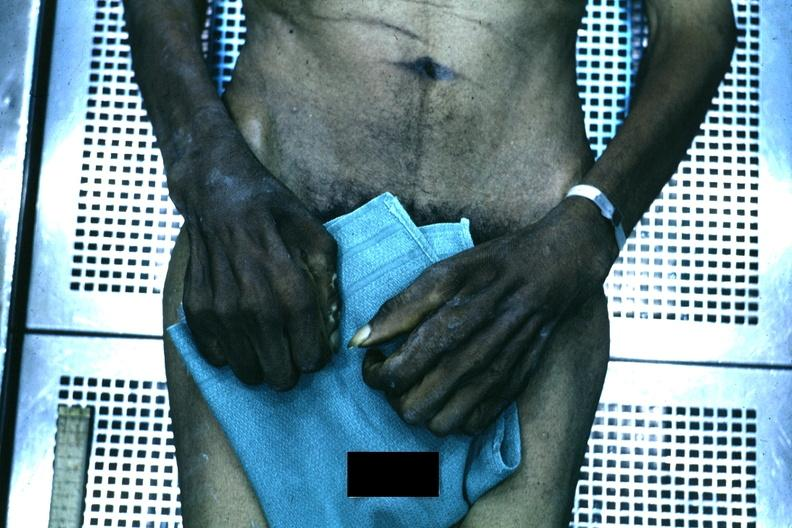does papillary intraductal adenocarcinoma show good example of muscle atrophy said to be due to syringomyelia?
Answer the question using a single word or phrase. No 